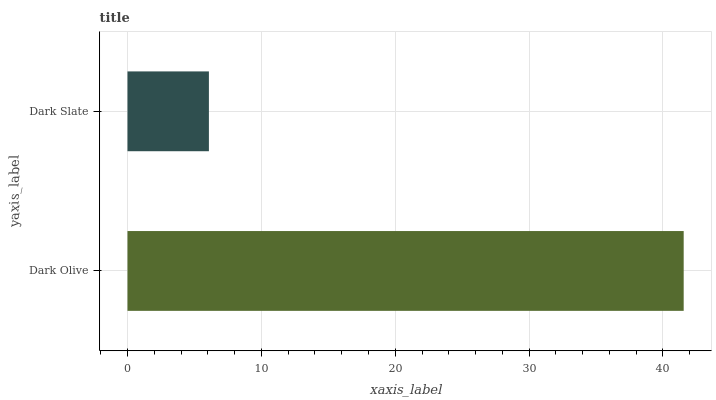Is Dark Slate the minimum?
Answer yes or no. Yes. Is Dark Olive the maximum?
Answer yes or no. Yes. Is Dark Slate the maximum?
Answer yes or no. No. Is Dark Olive greater than Dark Slate?
Answer yes or no. Yes. Is Dark Slate less than Dark Olive?
Answer yes or no. Yes. Is Dark Slate greater than Dark Olive?
Answer yes or no. No. Is Dark Olive less than Dark Slate?
Answer yes or no. No. Is Dark Olive the high median?
Answer yes or no. Yes. Is Dark Slate the low median?
Answer yes or no. Yes. Is Dark Slate the high median?
Answer yes or no. No. Is Dark Olive the low median?
Answer yes or no. No. 